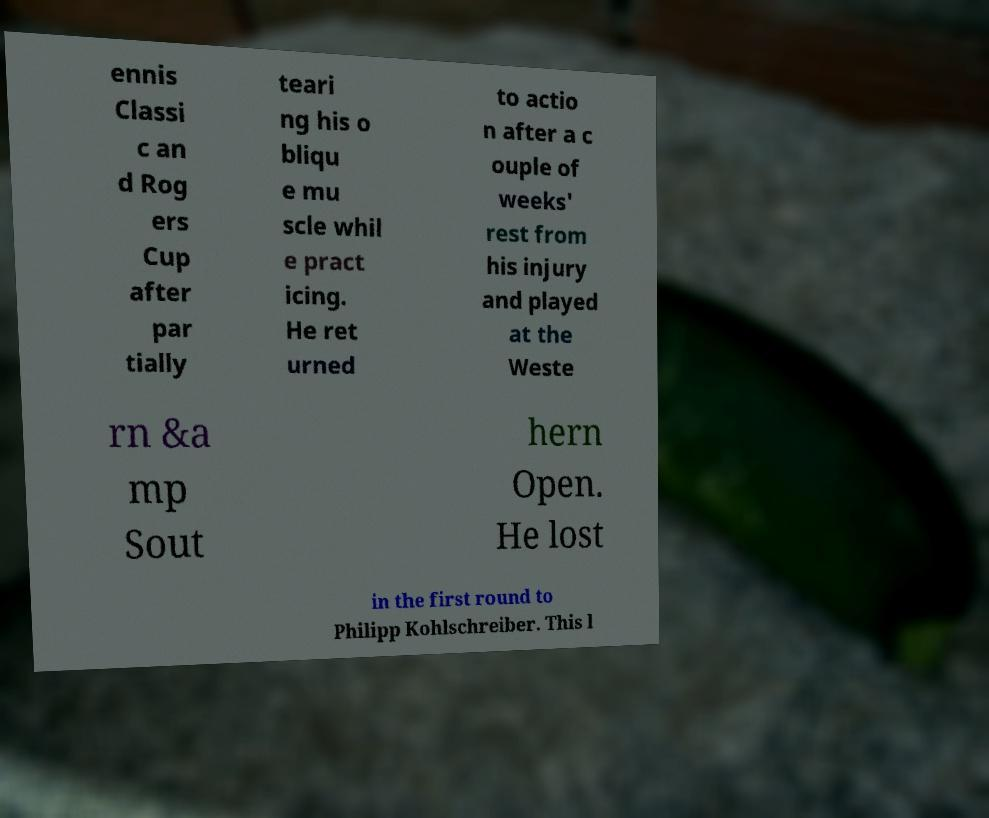Can you accurately transcribe the text from the provided image for me? ennis Classi c an d Rog ers Cup after par tially teari ng his o bliqu e mu scle whil e pract icing. He ret urned to actio n after a c ouple of weeks' rest from his injury and played at the Weste rn &a mp Sout hern Open. He lost in the first round to Philipp Kohlschreiber. This l 